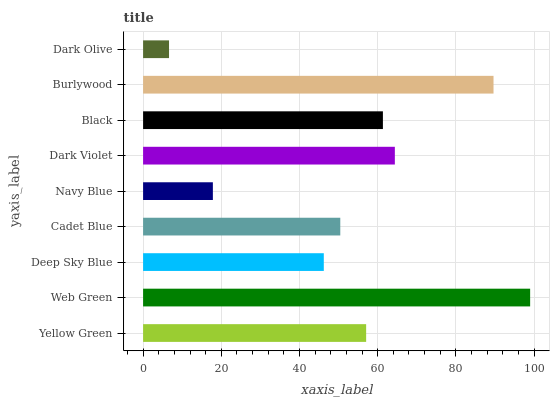Is Dark Olive the minimum?
Answer yes or no. Yes. Is Web Green the maximum?
Answer yes or no. Yes. Is Deep Sky Blue the minimum?
Answer yes or no. No. Is Deep Sky Blue the maximum?
Answer yes or no. No. Is Web Green greater than Deep Sky Blue?
Answer yes or no. Yes. Is Deep Sky Blue less than Web Green?
Answer yes or no. Yes. Is Deep Sky Blue greater than Web Green?
Answer yes or no. No. Is Web Green less than Deep Sky Blue?
Answer yes or no. No. Is Yellow Green the high median?
Answer yes or no. Yes. Is Yellow Green the low median?
Answer yes or no. Yes. Is Dark Olive the high median?
Answer yes or no. No. Is Navy Blue the low median?
Answer yes or no. No. 